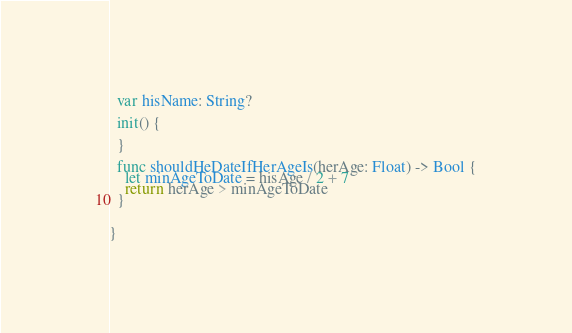Convert code to text. <code><loc_0><loc_0><loc_500><loc_500><_Swift_>  var hisName: String?
  
  init() {
    
  }
  
  func shouldHeDateIfHerAgeIs(herAge: Float) -> Bool {
    let minAgeToDate = hisAge / 2 + 7
    return herAge > minAgeToDate
  }
  
  
}
</code> 